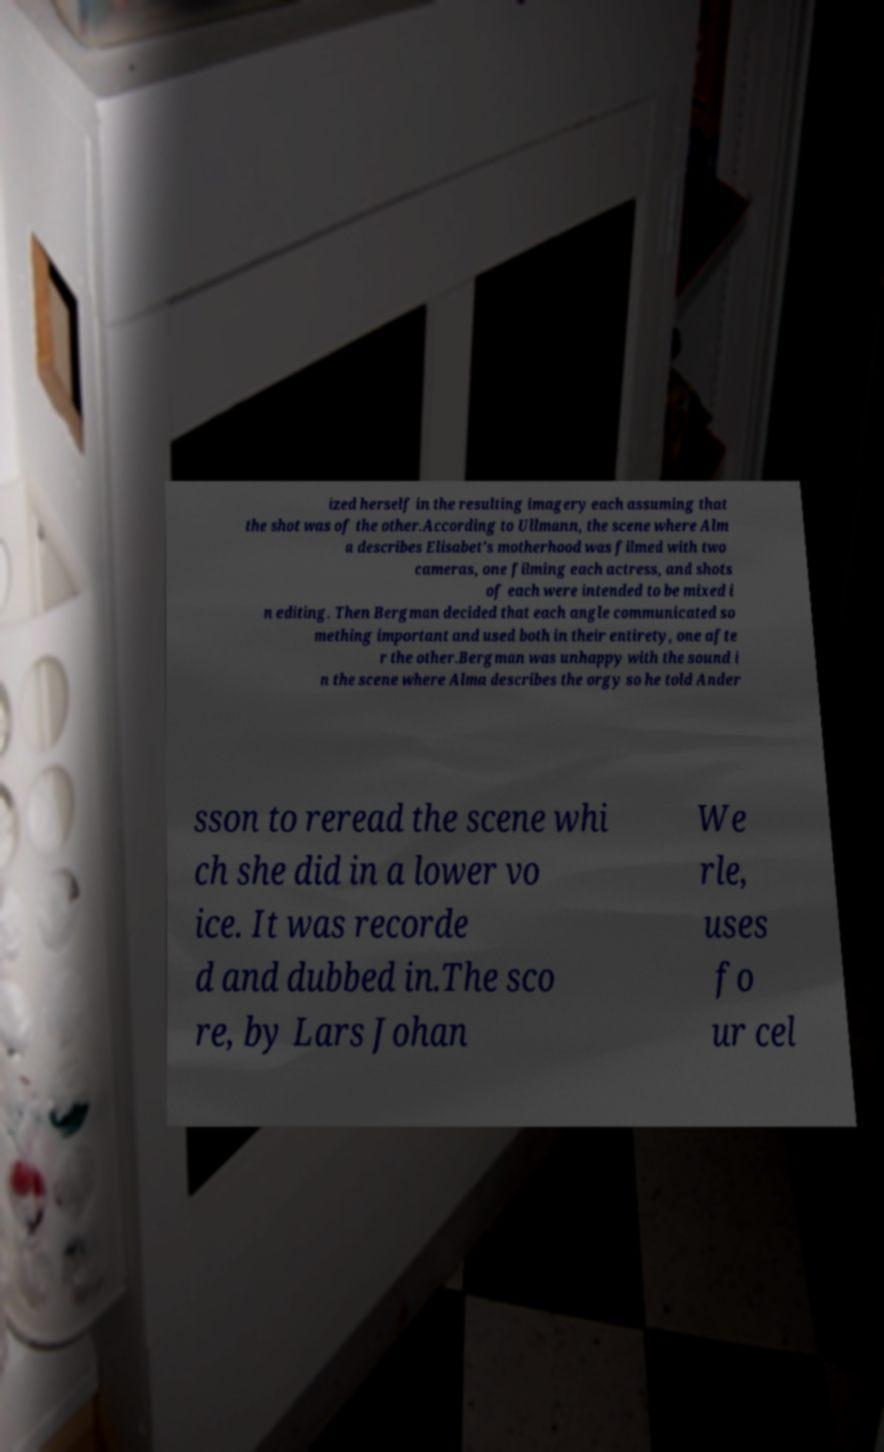Can you accurately transcribe the text from the provided image for me? ized herself in the resulting imagery each assuming that the shot was of the other.According to Ullmann, the scene where Alm a describes Elisabet's motherhood was filmed with two cameras, one filming each actress, and shots of each were intended to be mixed i n editing. Then Bergman decided that each angle communicated so mething important and used both in their entirety, one afte r the other.Bergman was unhappy with the sound i n the scene where Alma describes the orgy so he told Ander sson to reread the scene whi ch she did in a lower vo ice. It was recorde d and dubbed in.The sco re, by Lars Johan We rle, uses fo ur cel 